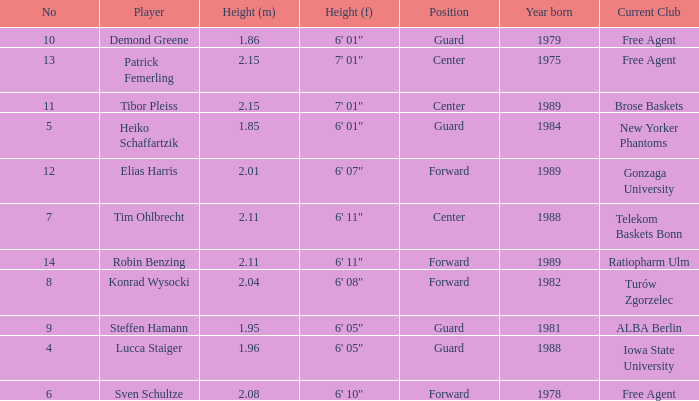Name the player that is 1.85 m Heiko Schaffartzik. Help me parse the entirety of this table. {'header': ['No', 'Player', 'Height (m)', 'Height (f)', 'Position', 'Year born', 'Current Club'], 'rows': [['10', 'Demond Greene', '1.86', '6\' 01"', 'Guard', '1979', 'Free Agent'], ['13', 'Patrick Femerling', '2.15', '7\' 01"', 'Center', '1975', 'Free Agent'], ['11', 'Tibor Pleiss', '2.15', '7\' 01"', 'Center', '1989', 'Brose Baskets'], ['5', 'Heiko Schaffartzik', '1.85', '6\' 01"', 'Guard', '1984', 'New Yorker Phantoms'], ['12', 'Elias Harris', '2.01', '6\' 07"', 'Forward', '1989', 'Gonzaga University'], ['7', 'Tim Ohlbrecht', '2.11', '6\' 11"', 'Center', '1988', 'Telekom Baskets Bonn'], ['14', 'Robin Benzing', '2.11', '6\' 11"', 'Forward', '1989', 'Ratiopharm Ulm'], ['8', 'Konrad Wysocki', '2.04', '6\' 08"', 'Forward', '1982', 'Turów Zgorzelec'], ['9', 'Steffen Hamann', '1.95', '6\' 05"', 'Guard', '1981', 'ALBA Berlin'], ['4', 'Lucca Staiger', '1.96', '6\' 05"', 'Guard', '1988', 'Iowa State University'], ['6', 'Sven Schultze', '2.08', '6\' 10"', 'Forward', '1978', 'Free Agent']]} 